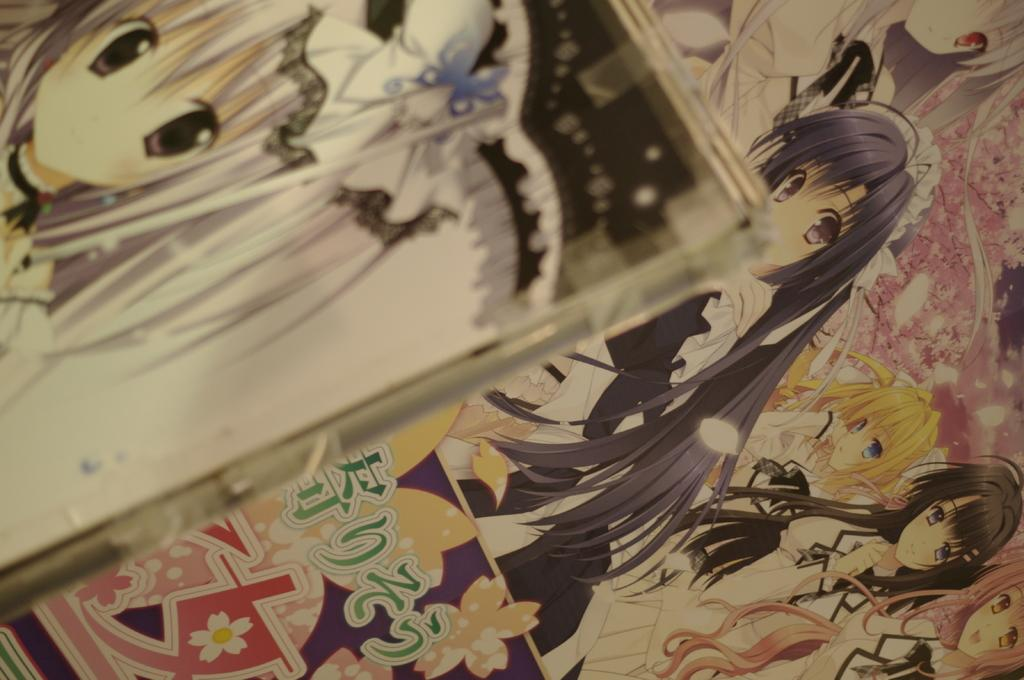What is located in the foreground of the image? There is a photo frame in the foreground of the image. Where is the photo frame positioned in the image? The photo frame is on the top of the image. What can be seen in the background of the image? There is a wall in the background of the image. What type of posters are present on the wall? Animated posters of women are present on the wall. What do the animated posters depict? The animated posters depict women. What type of unit is being served for dinner in the image? There is no mention of a unit or dinner in the image; it features a photo frame, a wall, and animated posters of women. 